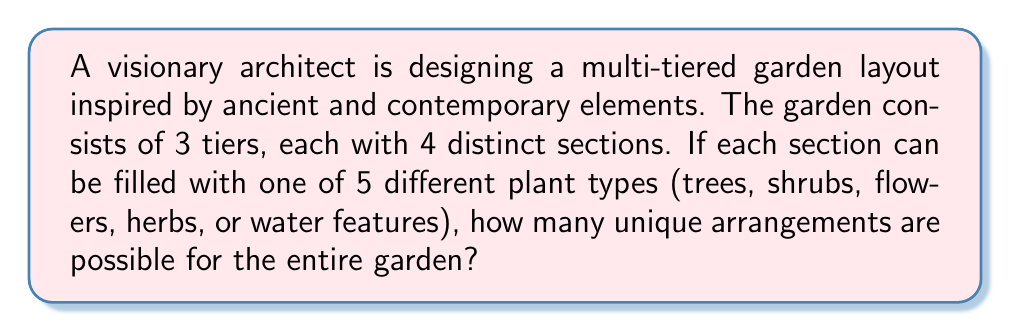Give your solution to this math problem. To solve this problem, we'll use the multiplication principle from combinatorics, which is closely related to Ring theory concepts.

1) First, let's consider a single section:
   - Each section can be filled with one of 5 plant types
   - So, for each individual section, there are 5 choices

2) Now, let's consider one tier:
   - Each tier has 4 distinct sections
   - For each section, we have 5 choices
   - The number of possibilities for one tier is therefore:
     $$ 5^4 = 625 $$

3) The entire garden consists of 3 tiers:
   - Each tier can be arranged independently of the others
   - We have 625 possibilities for each tier
   - Therefore, the total number of unique arrangements is:
     $$ 625^3 = (5^4)^3 = 5^{12} $$

4) Calculate the final result:
   $$ 5^{12} = 244,140,625 $$

This large number reflects the vast creative possibilities available to the architect, allowing for a fusion of ancient and contemporary elements in countless unique combinations.
Answer: $244,140,625$ unique arrangements 